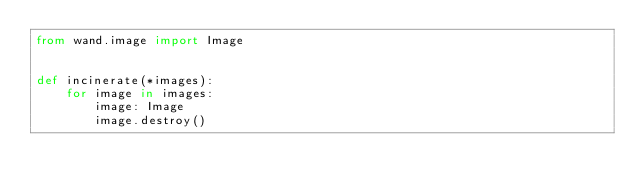Convert code to text. <code><loc_0><loc_0><loc_500><loc_500><_Python_>from wand.image import Image


def incinerate(*images):
    for image in images:
        image: Image
        image.destroy()
</code> 